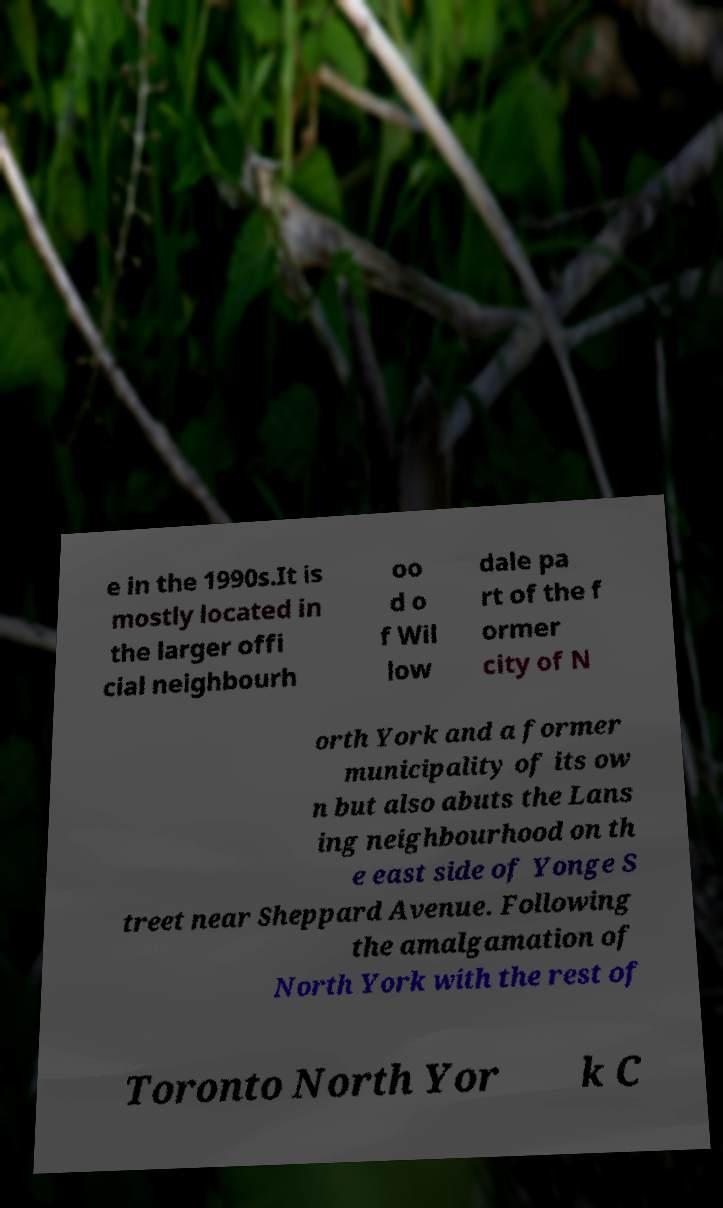I need the written content from this picture converted into text. Can you do that? e in the 1990s.It is mostly located in the larger offi cial neighbourh oo d o f Wil low dale pa rt of the f ormer city of N orth York and a former municipality of its ow n but also abuts the Lans ing neighbourhood on th e east side of Yonge S treet near Sheppard Avenue. Following the amalgamation of North York with the rest of Toronto North Yor k C 